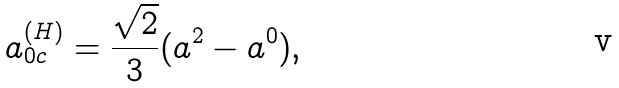Convert formula to latex. <formula><loc_0><loc_0><loc_500><loc_500>a _ { 0 c } ^ { ( H ) } = \frac { \sqrt { 2 } } { 3 } ( a ^ { 2 } - a ^ { 0 } ) ,</formula> 